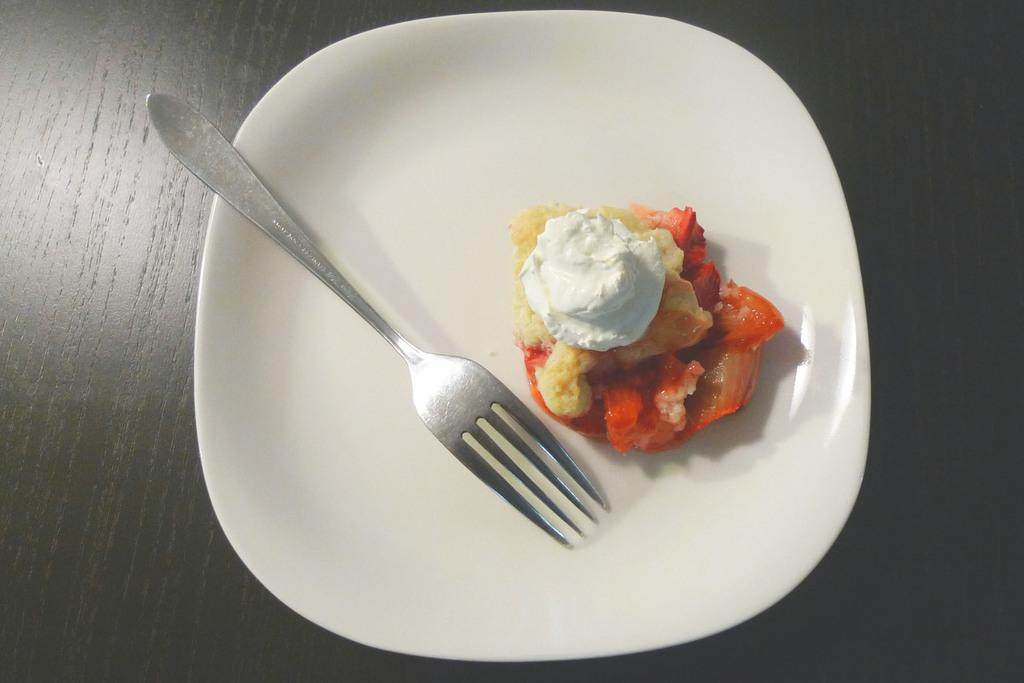What is present on the wooden surface in the image? There is a plate on the wooden surface. What is on the plate? There is a fork and a food item on the plate. What type of utensil is on the plate? There is a fork on the plate. What unit of measurement is used to describe the size of the clam on the plate? There is no clam present on the plate in the image. 